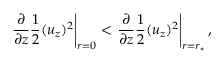Convert formula to latex. <formula><loc_0><loc_0><loc_500><loc_500>{ \frac { \partial } { \partial z } \frac { 1 } { 2 } ( u _ { z } ) ^ { 2 } } \right | _ { r = 0 } < { \frac { \partial } { \partial z } \frac { 1 } { 2 } ( u _ { z } ) ^ { 2 } } \right | _ { r = r _ { \ast } } ,</formula> 